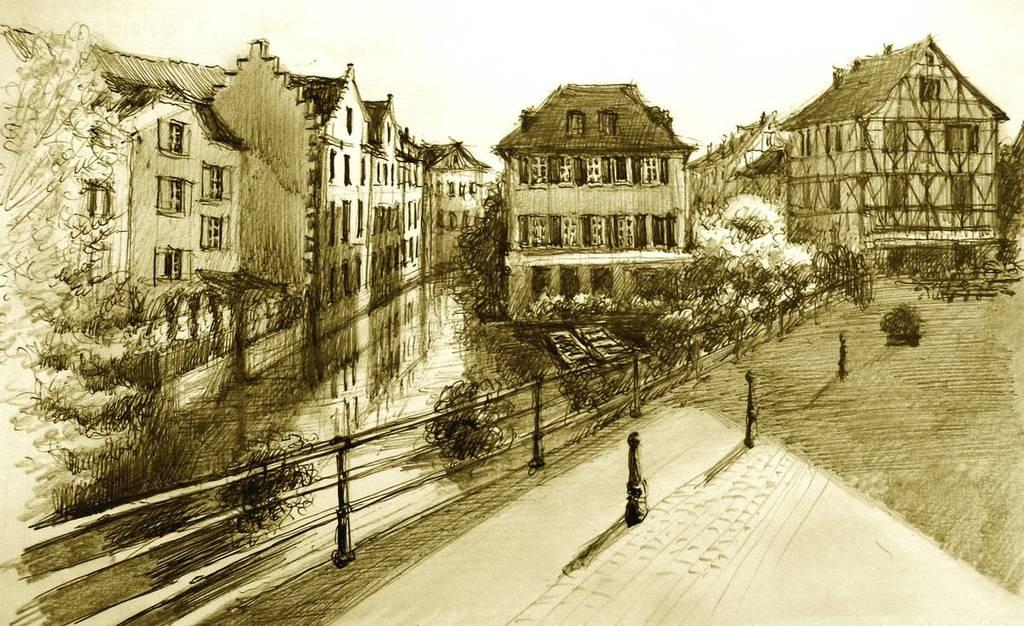What type of drawing is present in the image? The image contains a sketch of trees, fencing, and a building. Can you describe the sketch of trees? The sketch of trees shows a representation of trees in the image. What other structures are depicted in the sketch? The sketch also includes a depiction of fencing and a building. How many fingers can be seen holding the sketch in the image? There are no fingers visible in the image, as it is a sketch and not a photograph or video. 